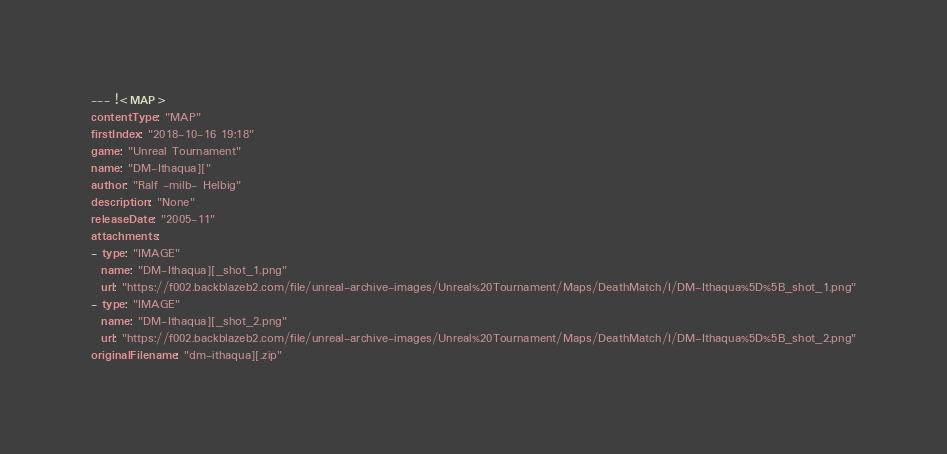<code> <loc_0><loc_0><loc_500><loc_500><_YAML_>--- !<MAP>
contentType: "MAP"
firstIndex: "2018-10-16 19:18"
game: "Unreal Tournament"
name: "DM-Ithaqua]["
author: "Ralf -milb- Helbig"
description: "None"
releaseDate: "2005-11"
attachments:
- type: "IMAGE"
  name: "DM-Ithaqua][_shot_1.png"
  url: "https://f002.backblazeb2.com/file/unreal-archive-images/Unreal%20Tournament/Maps/DeathMatch/I/DM-Ithaqua%5D%5B_shot_1.png"
- type: "IMAGE"
  name: "DM-Ithaqua][_shot_2.png"
  url: "https://f002.backblazeb2.com/file/unreal-archive-images/Unreal%20Tournament/Maps/DeathMatch/I/DM-Ithaqua%5D%5B_shot_2.png"
originalFilename: "dm-ithaqua][.zip"</code> 